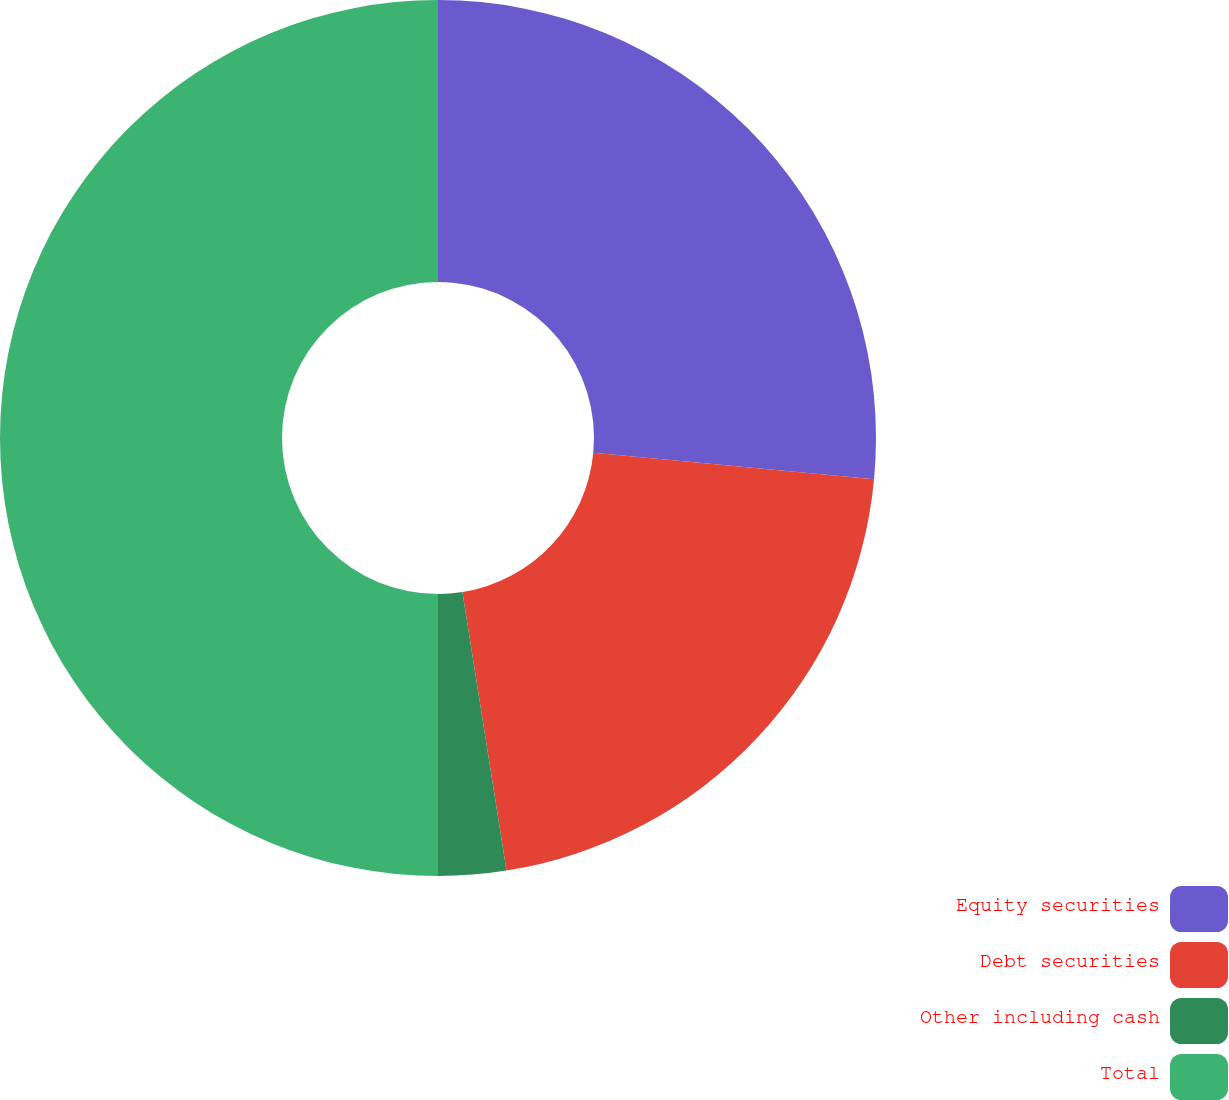<chart> <loc_0><loc_0><loc_500><loc_500><pie_chart><fcel>Equity securities<fcel>Debt securities<fcel>Other including cash<fcel>Total<nl><fcel>26.5%<fcel>21.0%<fcel>2.5%<fcel>50.0%<nl></chart> 